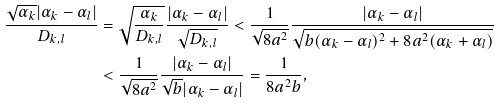<formula> <loc_0><loc_0><loc_500><loc_500>\frac { \sqrt { \alpha _ { k } } | \alpha _ { k } - \alpha _ { l } | } { D _ { k , l } } & = \sqrt { \frac { \alpha _ { k } } { D _ { k , l } } } \frac { | \alpha _ { k } - \alpha _ { l } | } { \sqrt { D _ { k , l } } } < \frac { 1 } { \sqrt { 8 a ^ { 2 } } } \frac { | \alpha _ { k } - \alpha _ { l } | } { \sqrt { b ( \alpha _ { k } - \alpha _ { l } ) ^ { 2 } + 8 a ^ { 2 } ( \alpha _ { k } + \alpha _ { l } ) } } \\ & < \frac { 1 } { \sqrt { 8 a ^ { 2 } } } \frac { | \alpha _ { k } - \alpha _ { l } | } { \sqrt { b } | \alpha _ { k } - \alpha _ { l } | } = \frac { 1 } { 8 a ^ { 2 } b } ,</formula> 